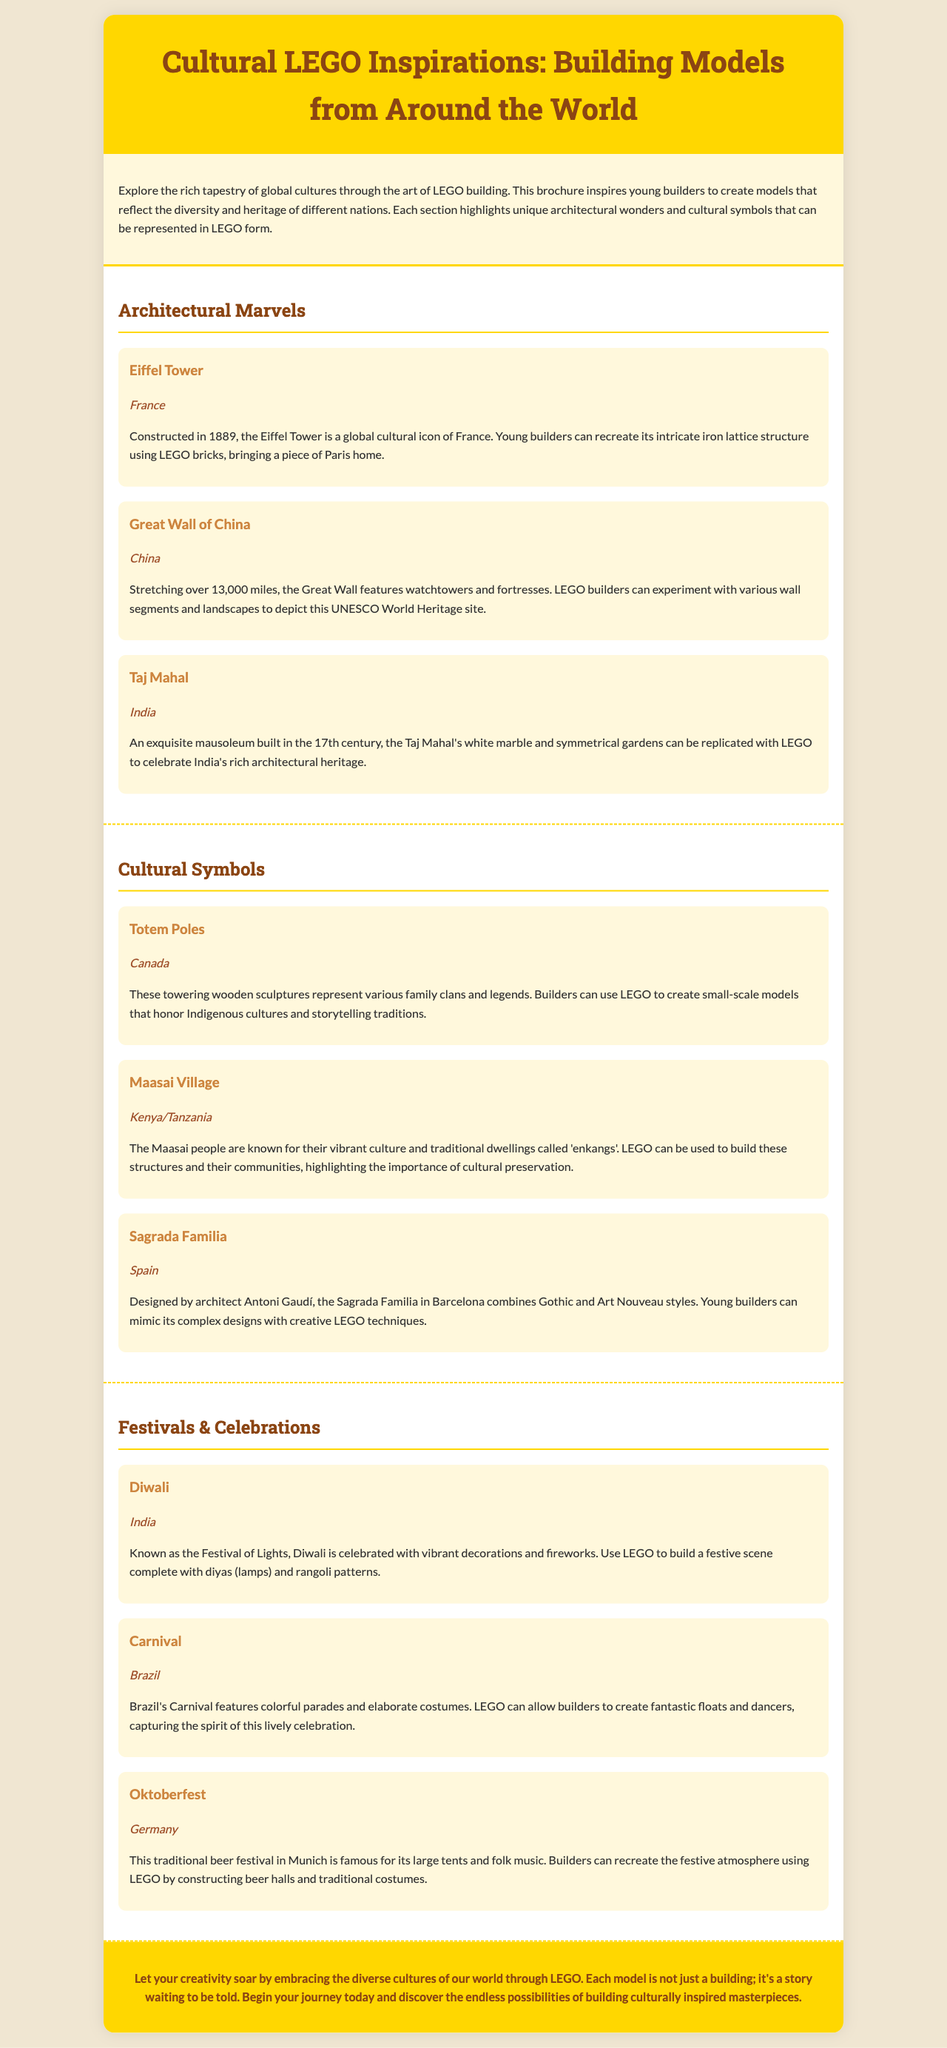What is the title of the brochure? The title is presented prominently at the top of the document and summarizes the main theme.
Answer: Cultural LEGO Inspirations: Building Models from Around the World Which country is associated with the Eiffel Tower? The document specifies the country in which each landmark is located, describing its cultural significance.
Answer: France What is the significance of the Great Wall of China in the document? The document describes the Great Wall as featuring watchtowers and fortresses, emphasizing its historical importance and suggested building aspects.
Answer: UNESCO World Heritage site How many sections are there in the brochure? The document is divided into distinct sections, each focusing on a specific aspect of cultural LEGO building.
Answer: Three What festival is known as the Festival of Lights? The document names specific festivals and their cultural background, highlighting the unique celebrations in each case.
Answer: Diwali Which two countries are represented in the Maasai Village description? The document explicitly lists countries associated with cultural symbols, providing insight into their geographical context.
Answer: Kenya/Tanzania What type of models can be built to celebrate the Carnival? The brochure suggests building specific representations tied to each festival, indicating what aspects to focus on while building.
Answer: Floats and dancers What architectural style is the Sagrada Familia designed in? The document briefly explains the architectural significance of the structure and the style it embodies.
Answer: Gothic and Art Nouveau styles What can builders create to honor Indigenous cultures according to the document? The document outlines the possibilities of using LEGO to represent cultural artifacts, giving examples from various traditions.
Answer: Small-scale models 